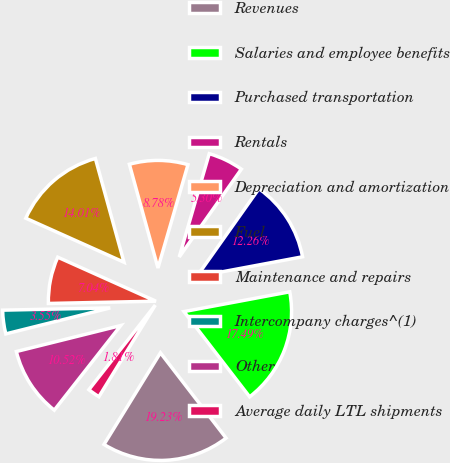Convert chart to OTSL. <chart><loc_0><loc_0><loc_500><loc_500><pie_chart><fcel>Revenues<fcel>Salaries and employee benefits<fcel>Purchased transportation<fcel>Rentals<fcel>Depreciation and amortization<fcel>Fuel<fcel>Maintenance and repairs<fcel>Intercompany charges^(1)<fcel>Other<fcel>Average daily LTL shipments<nl><fcel>19.23%<fcel>17.49%<fcel>12.26%<fcel>5.3%<fcel>8.78%<fcel>14.01%<fcel>7.04%<fcel>3.55%<fcel>10.52%<fcel>1.81%<nl></chart> 